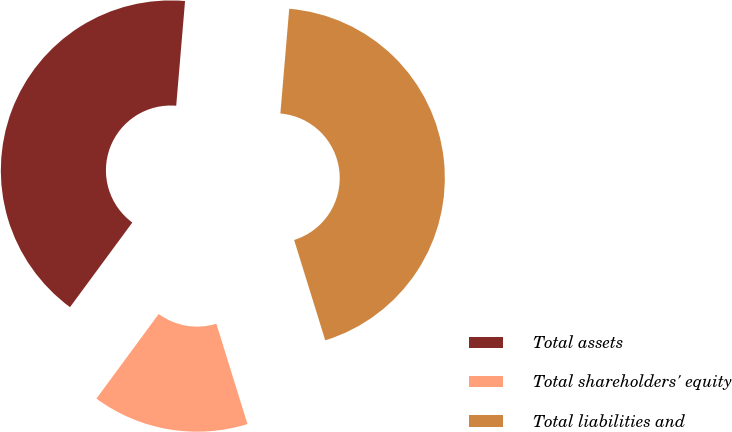<chart> <loc_0><loc_0><loc_500><loc_500><pie_chart><fcel>Total assets<fcel>Total shareholders' equity<fcel>Total liabilities and<nl><fcel>41.24%<fcel>14.89%<fcel>43.87%<nl></chart> 